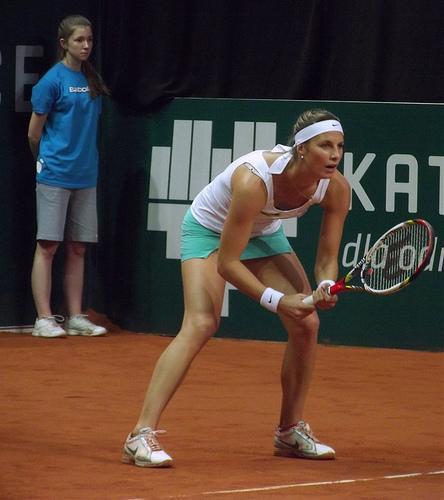How many people seen on the court?
Give a very brief answer. 2. 